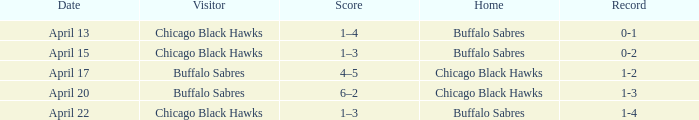Which Date has a Record of 1-4? April 22. 